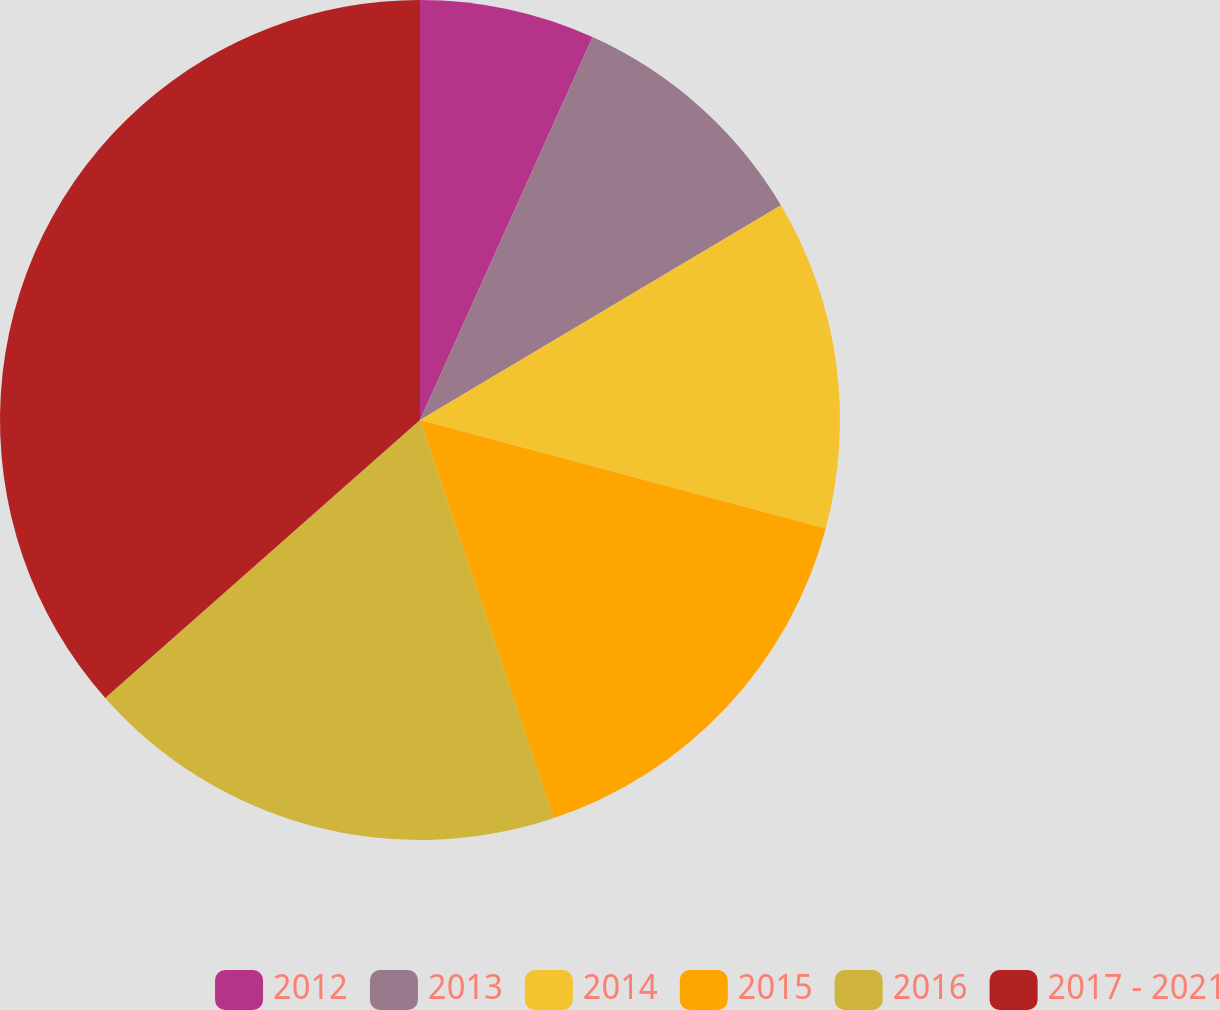Convert chart to OTSL. <chart><loc_0><loc_0><loc_500><loc_500><pie_chart><fcel>2012<fcel>2013<fcel>2014<fcel>2015<fcel>2016<fcel>2017 - 2021<nl><fcel>6.74%<fcel>9.72%<fcel>12.7%<fcel>15.67%<fcel>18.65%<fcel>36.51%<nl></chart> 